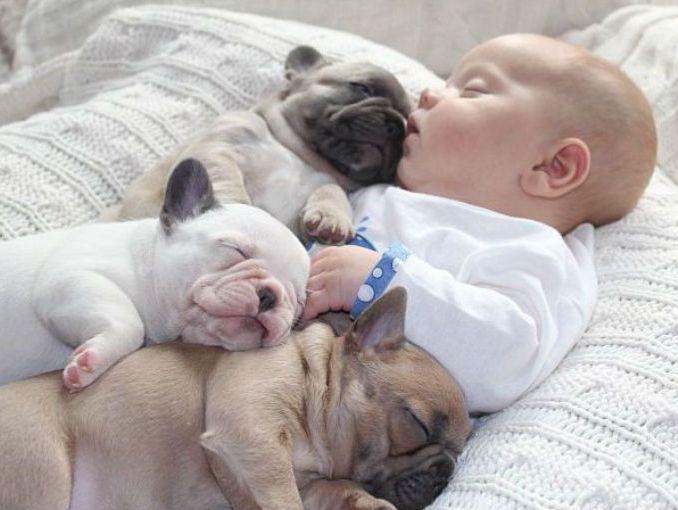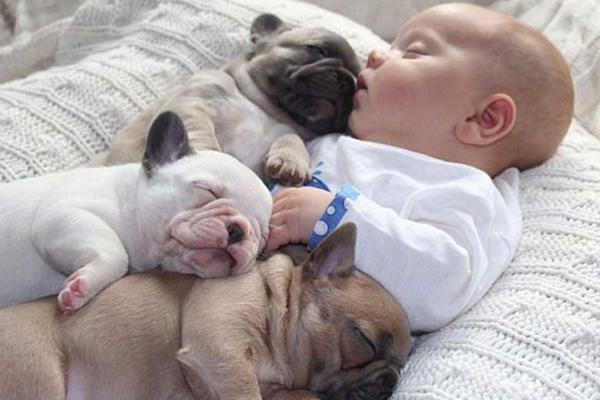The first image is the image on the left, the second image is the image on the right. For the images shown, is this caption "The right image contains at least three dogs." true? Answer yes or no. Yes. 